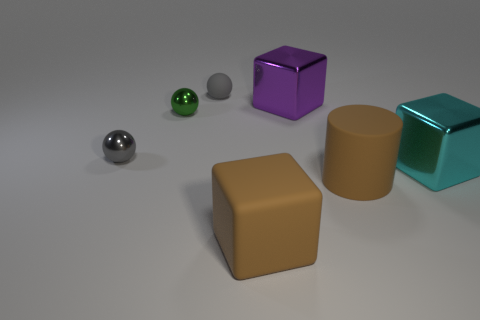There is a object in front of the brown matte object behind the large cube in front of the brown cylinder; what is its color?
Make the answer very short. Brown. How many other things are the same color as the small matte ball?
Give a very brief answer. 1. Is the number of cyan objects less than the number of tiny gray metal cubes?
Provide a succinct answer. No. There is a large block that is both behind the brown cylinder and to the left of the brown cylinder; what color is it?
Your response must be concise. Purple. There is another tiny gray object that is the same shape as the tiny gray metal object; what material is it?
Your answer should be very brief. Rubber. Is the number of small cyan rubber spheres greater than the number of matte cylinders?
Give a very brief answer. No. What size is the metallic object that is both in front of the tiny green sphere and behind the cyan block?
Provide a succinct answer. Small. The green object is what shape?
Keep it short and to the point. Sphere. What number of other big matte things are the same shape as the cyan object?
Your answer should be compact. 1. Is the number of brown cubes that are to the right of the gray matte thing less than the number of gray objects behind the large matte cube?
Offer a very short reply. Yes. 